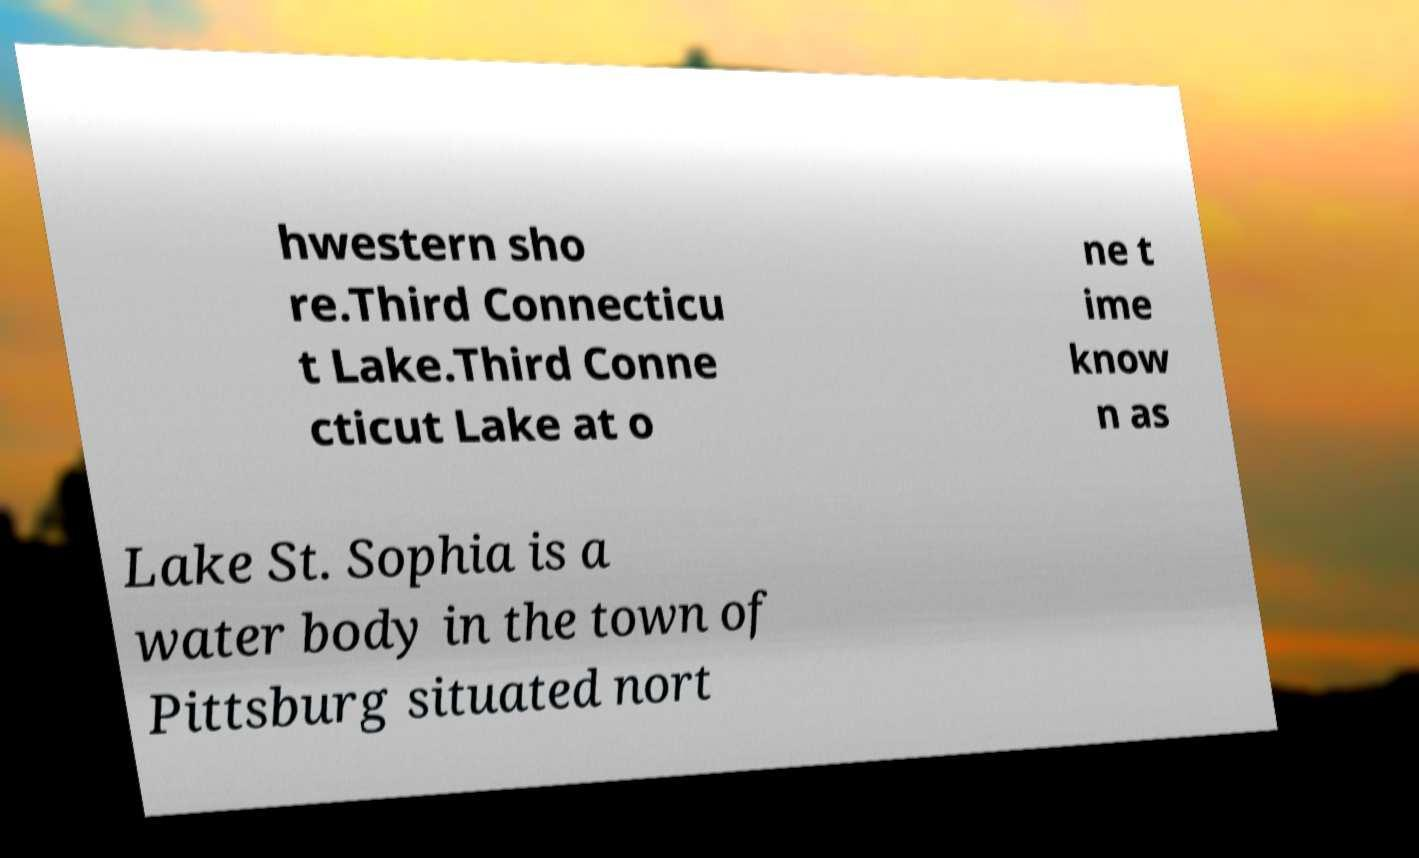I need the written content from this picture converted into text. Can you do that? hwestern sho re.Third Connecticu t Lake.Third Conne cticut Lake at o ne t ime know n as Lake St. Sophia is a water body in the town of Pittsburg situated nort 